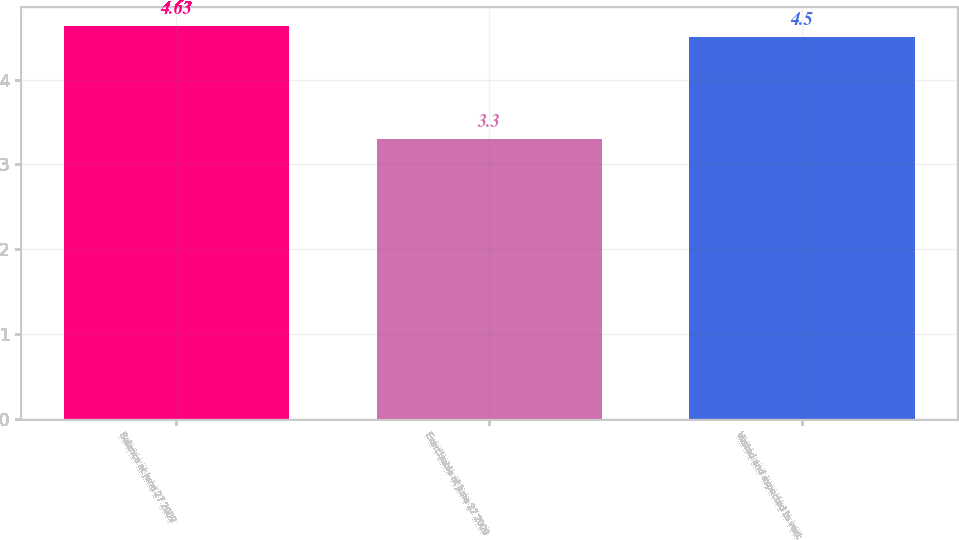<chart> <loc_0><loc_0><loc_500><loc_500><bar_chart><fcel>Balance at June 27 2009<fcel>Exercisable at June 27 2009<fcel>Vested and expected to vest<nl><fcel>4.63<fcel>3.3<fcel>4.5<nl></chart> 